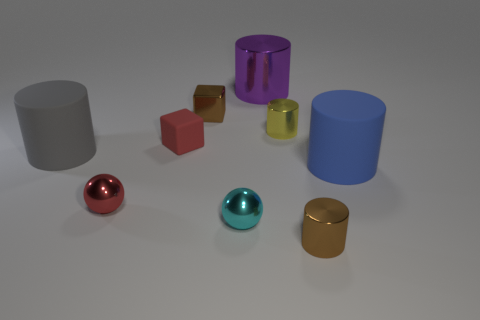Is there a large metal object that has the same color as the metal block?
Offer a very short reply. No. What is the small cyan thing made of?
Provide a short and direct response. Metal. What number of large matte cylinders are there?
Provide a succinct answer. 2. Does the tiny sphere on the left side of the small metallic cube have the same color as the tiny cylinder that is in front of the cyan shiny ball?
Keep it short and to the point. No. The thing that is the same color as the metallic block is what size?
Your answer should be compact. Small. What number of other things are the same size as the red metallic ball?
Provide a short and direct response. 5. What color is the large rubber cylinder on the left side of the large metal object?
Give a very brief answer. Gray. Is the blue cylinder that is in front of the yellow object made of the same material as the red sphere?
Give a very brief answer. No. How many metallic objects are behind the red ball and in front of the red metallic ball?
Ensure brevity in your answer.  0. What color is the matte thing in front of the matte cylinder that is to the left of the tiny brown metallic object that is right of the yellow shiny object?
Provide a short and direct response. Blue. 